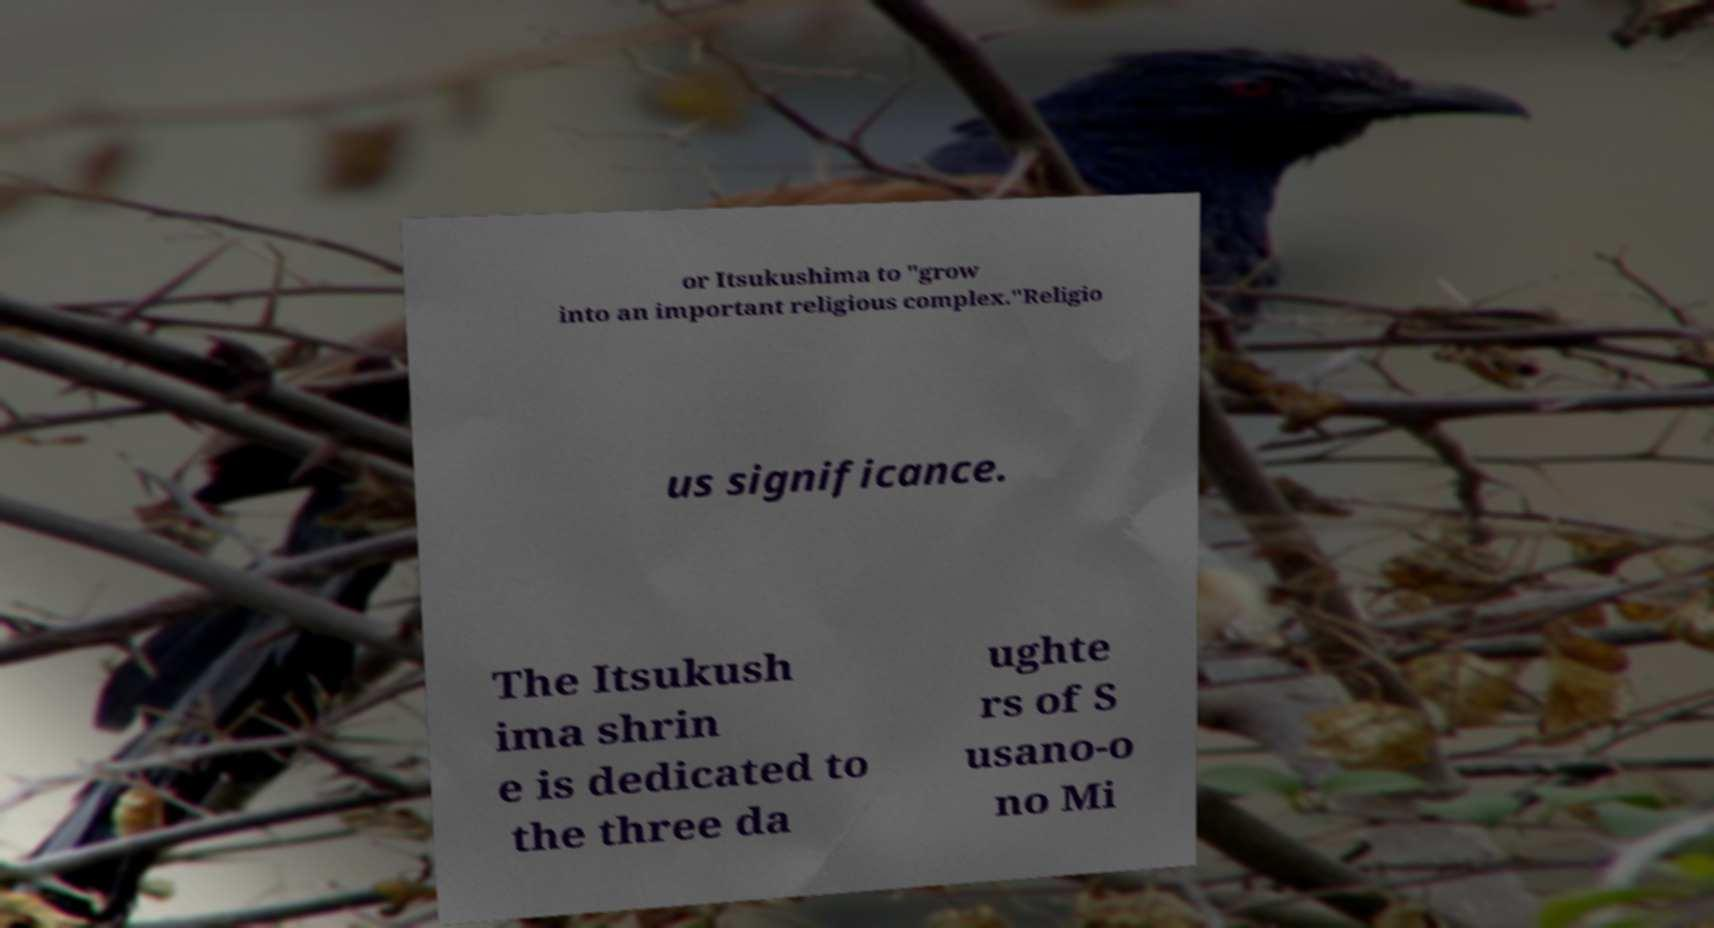Please read and relay the text visible in this image. What does it say? or Itsukushima to "grow into an important religious complex."Religio us significance. The Itsukush ima shrin e is dedicated to the three da ughte rs of S usano-o no Mi 